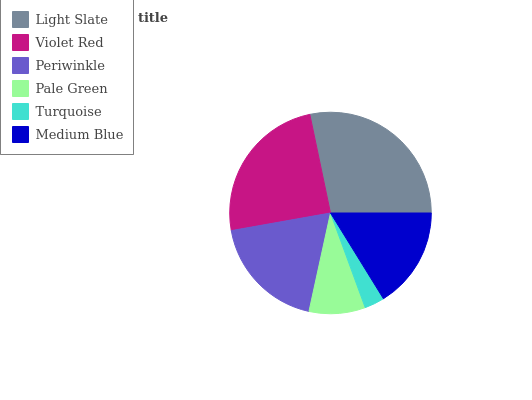Is Turquoise the minimum?
Answer yes or no. Yes. Is Light Slate the maximum?
Answer yes or no. Yes. Is Violet Red the minimum?
Answer yes or no. No. Is Violet Red the maximum?
Answer yes or no. No. Is Light Slate greater than Violet Red?
Answer yes or no. Yes. Is Violet Red less than Light Slate?
Answer yes or no. Yes. Is Violet Red greater than Light Slate?
Answer yes or no. No. Is Light Slate less than Violet Red?
Answer yes or no. No. Is Periwinkle the high median?
Answer yes or no. Yes. Is Medium Blue the low median?
Answer yes or no. Yes. Is Medium Blue the high median?
Answer yes or no. No. Is Light Slate the low median?
Answer yes or no. No. 